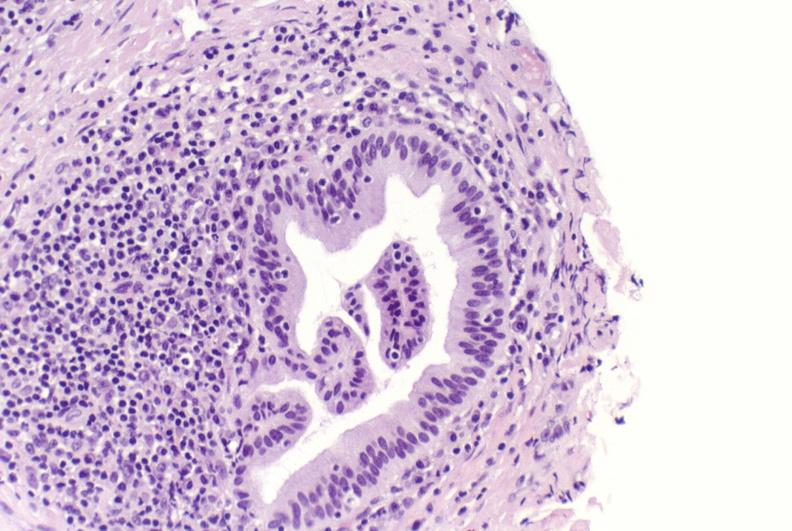does malignant adenoma show primary biliary cirrhosis?
Answer the question using a single word or phrase. No 